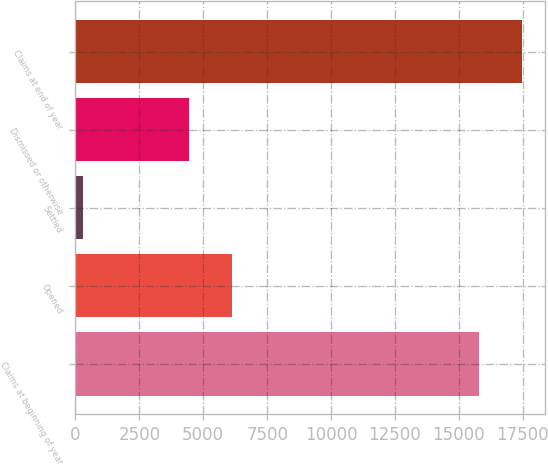Convert chart. <chart><loc_0><loc_0><loc_500><loc_500><bar_chart><fcel>Claims at beginning of year<fcel>Opened<fcel>Settled<fcel>Dismissed or otherwise<fcel>Claims at end of year<nl><fcel>15791<fcel>6134<fcel>286<fcel>4446<fcel>17479<nl></chart> 